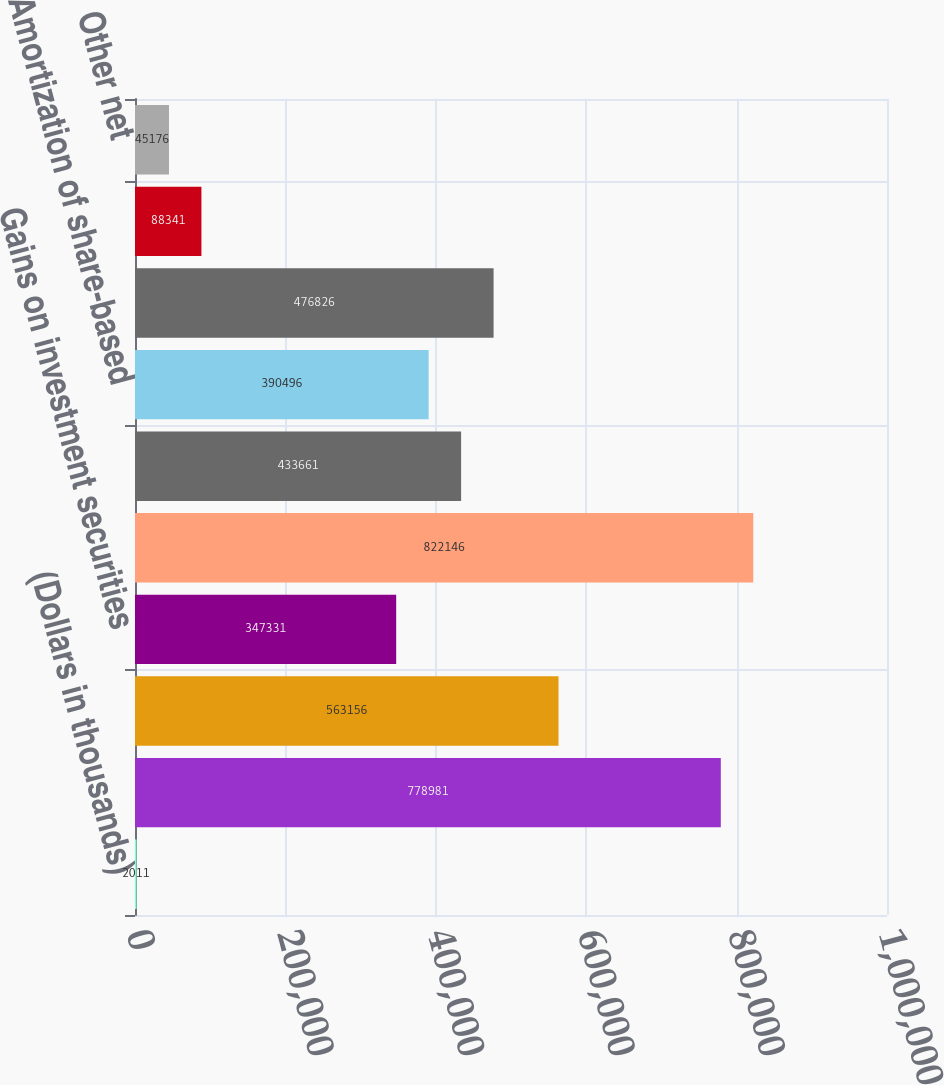Convert chart to OTSL. <chart><loc_0><loc_0><loc_500><loc_500><bar_chart><fcel>(Dollars in thousands)<fcel>Net income attributable to<fcel>Gains on derivative<fcel>Gains on investment securities<fcel>Net income of bank subsidiary<fcel>Net income on nonbank<fcel>Amortization of share-based<fcel>Decrease in other assets<fcel>Increase in other liabilities<fcel>Other net<nl><fcel>2011<fcel>778981<fcel>563156<fcel>347331<fcel>822146<fcel>433661<fcel>390496<fcel>476826<fcel>88341<fcel>45176<nl></chart> 